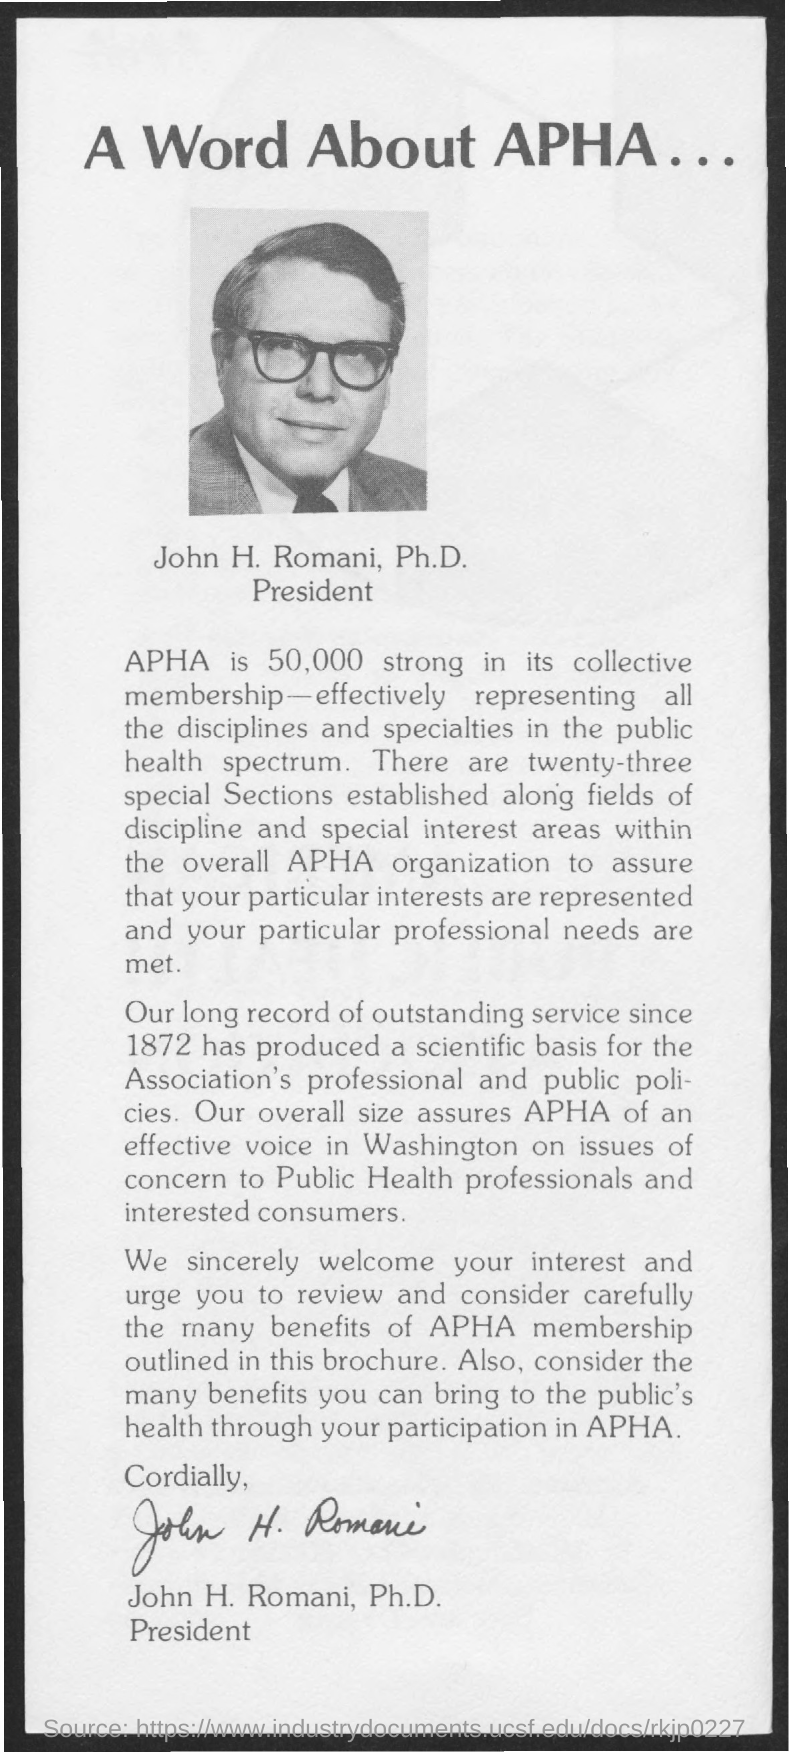Highlight a few significant elements in this photo. John H. Romani is the President. 